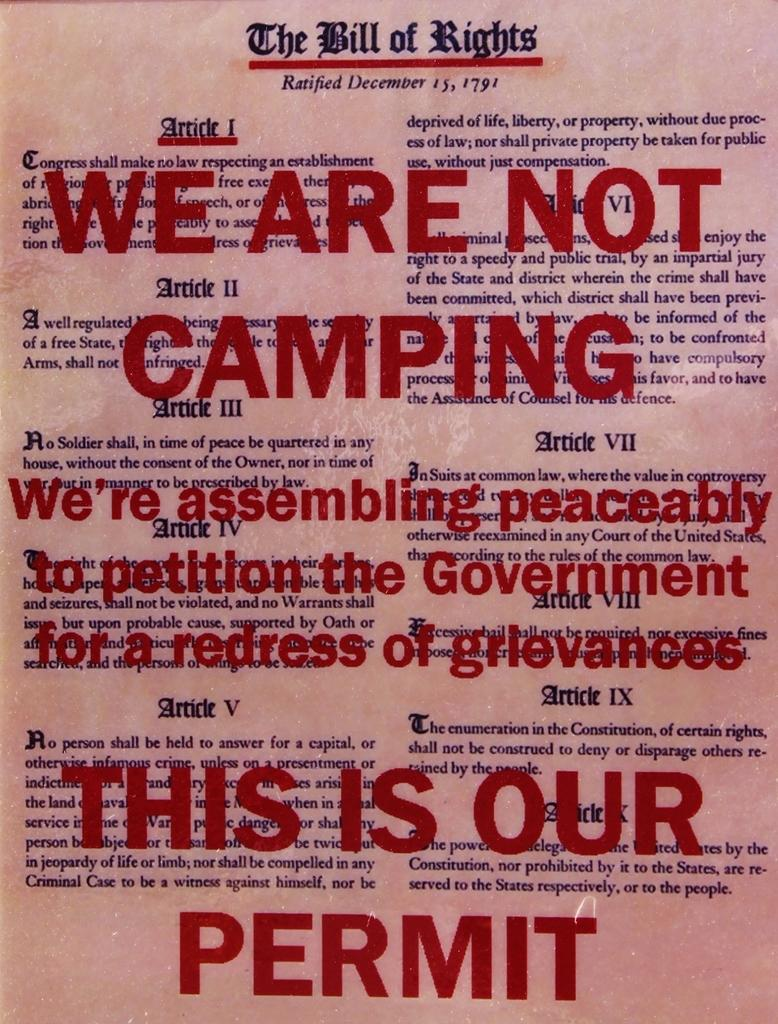<image>
Render a clear and concise summary of the photo. Text stating that "we are not camping" is written over a copy of The Bill Of Rights. 